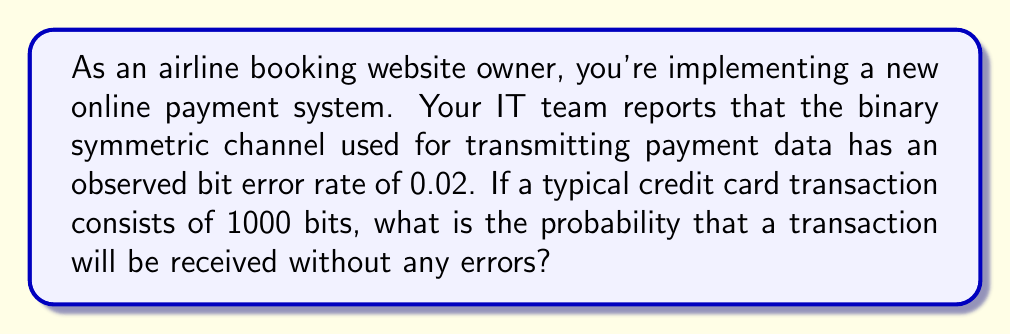What is the answer to this math problem? To solve this problem, we need to use concepts from information theory, specifically related to the binary symmetric channel (BSC) and error probability.

1. In a BSC, each bit has an independent probability of being flipped (error). The probability of a bit being correct is $1 - p$, where $p$ is the bit error rate.

2. For a transaction to be received without errors, all bits must be transmitted correctly.

3. Given:
   - Bit error rate, $p = 0.02$
   - Number of bits in a transaction, $n = 1000$

4. Probability of a single bit being correct: $1 - p = 1 - 0.02 = 0.98$

5. For all bits to be correct, we need this to happen $n$ times independently. We can use the multiplication rule of probability for independent events.

6. The probability of all bits being correct is:

   $$(1-p)^n = (0.98)^{1000}$$

7. We can calculate this using logarithms to avoid numerical underflow:

   $$\log((1-p)^n) = n \log(1-p) = 1000 \log(0.98) \approx -20.2027$$

8. Therefore, the probability is:

   $$e^{-20.2027} \approx 1.6653 \times 10^{-9}$$

This extremely low probability illustrates why error detection and correction mechanisms are crucial in digital communication systems, especially for financial transactions.
Answer: The probability that a transaction will be received without any errors is approximately $1.6653 \times 10^{-9}$ or about 0.00000017%. 